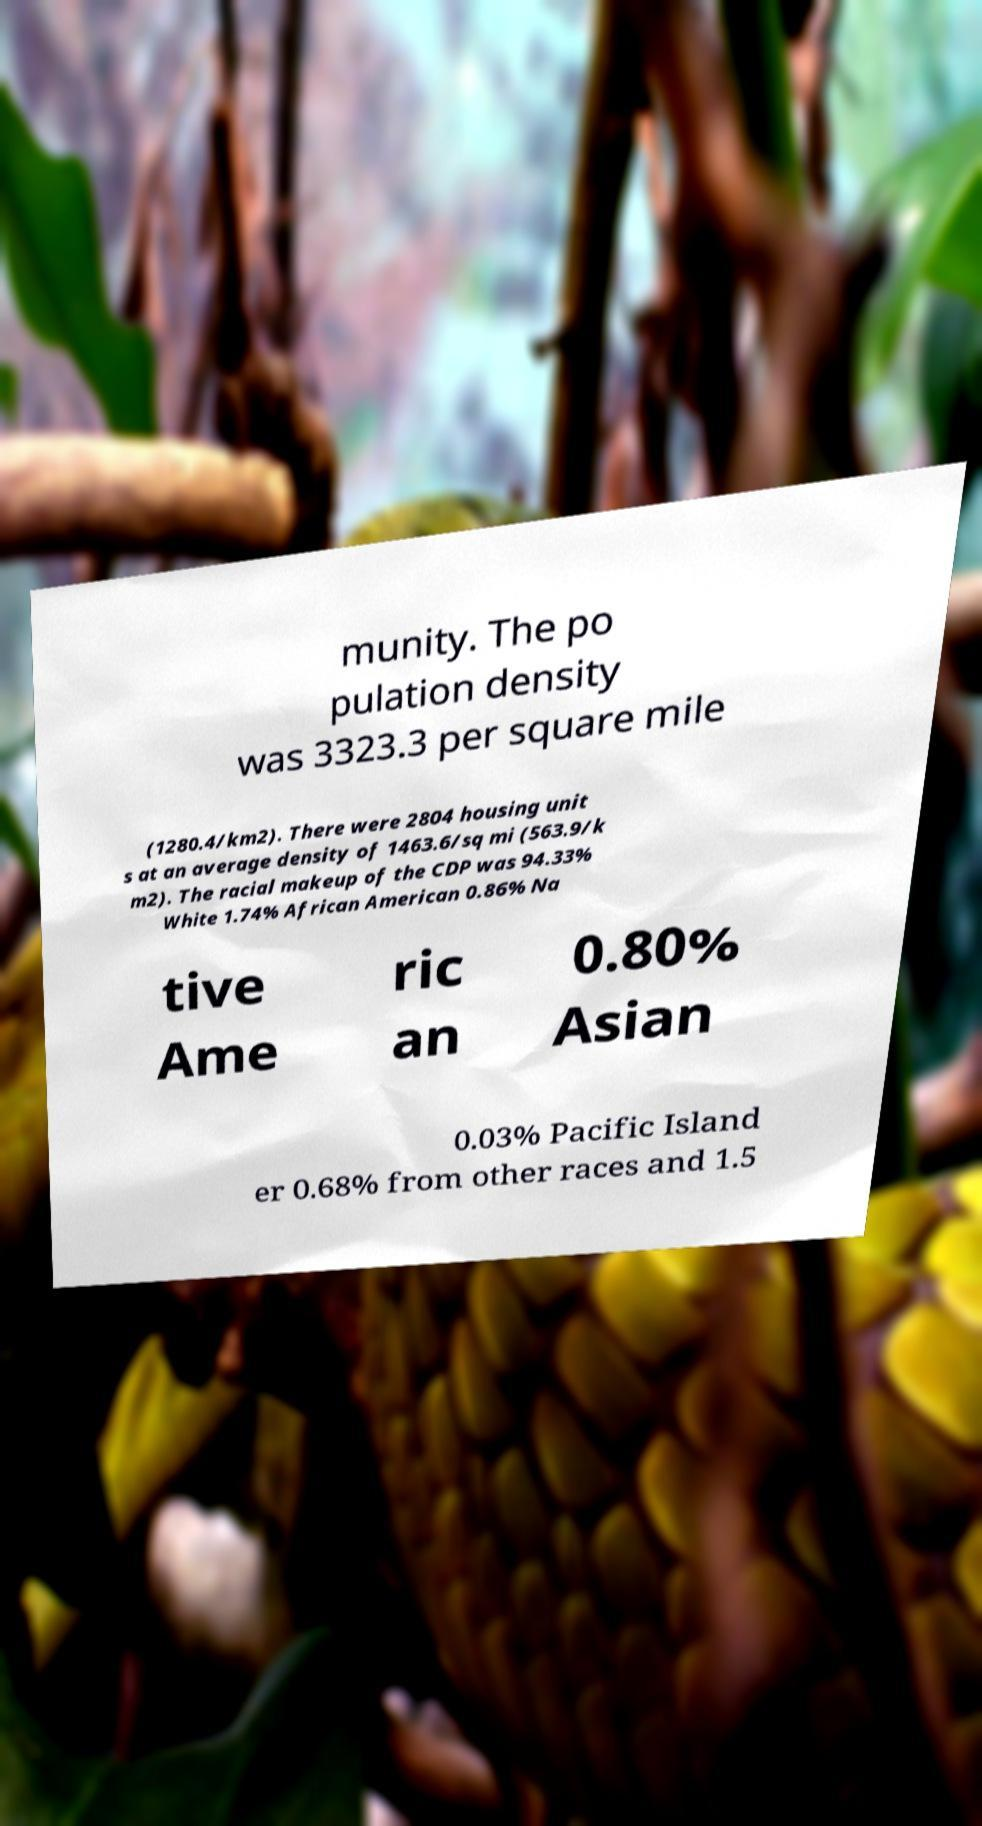Can you accurately transcribe the text from the provided image for me? munity. The po pulation density was 3323.3 per square mile (1280.4/km2). There were 2804 housing unit s at an average density of 1463.6/sq mi (563.9/k m2). The racial makeup of the CDP was 94.33% White 1.74% African American 0.86% Na tive Ame ric an 0.80% Asian 0.03% Pacific Island er 0.68% from other races and 1.5 